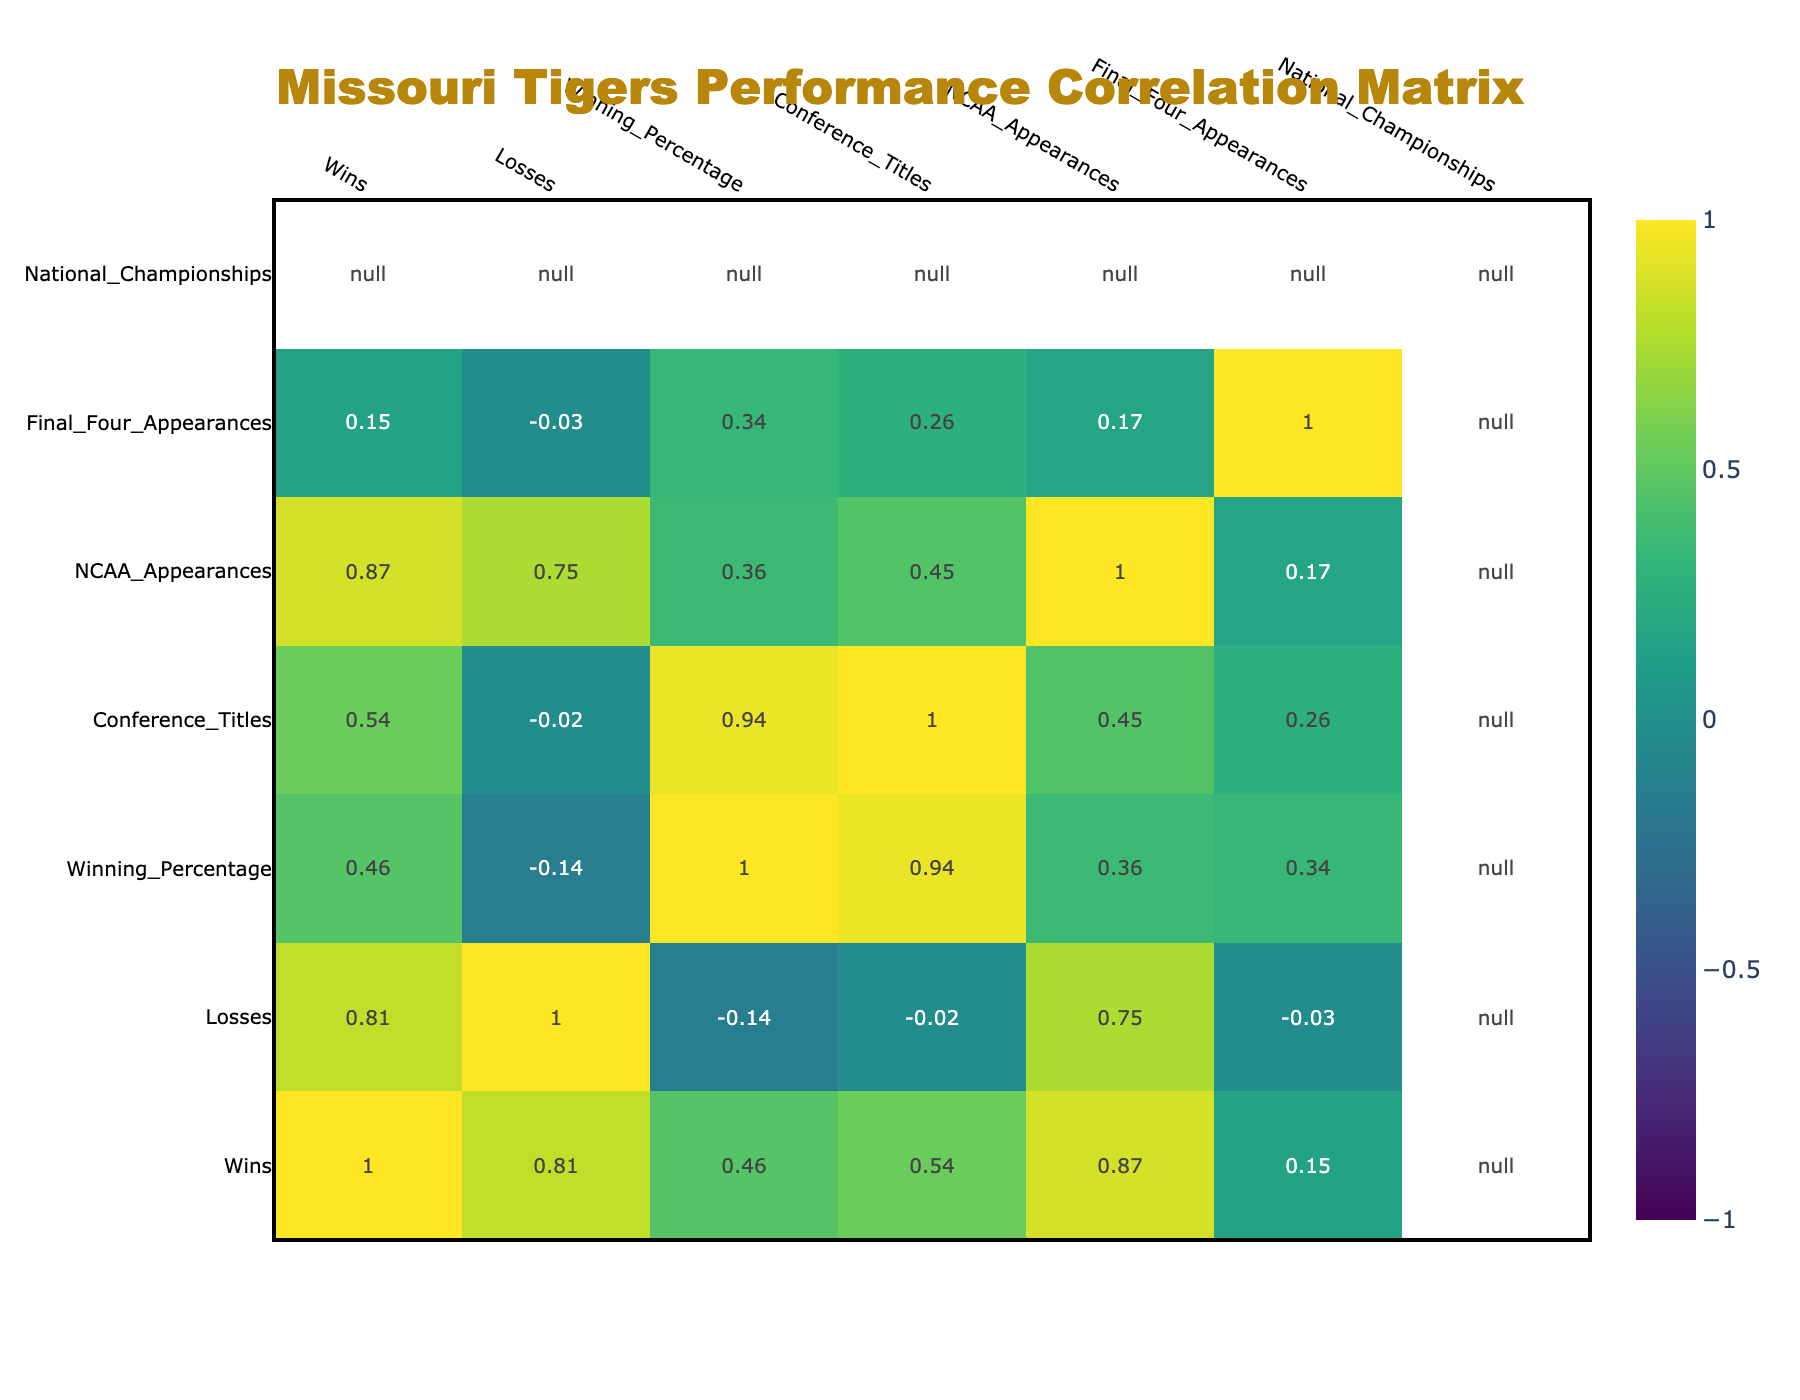What was the winning percentage of the Missouri Tigers in the 1980s? The table shows the winning percentage for the 1980s is listed under the "Winning_Percentage" column next to the "1980s" row. The value is 0.642.
Answer: 0.642 Which decade had the highest number of NCAA appearances? To find the decade with the highest number of NCAA appearances, I look under the "NCAA_Appearances" column and identify the maximum value. The 1990s has 7 appearances, which is the highest.
Answer: 1990s Is it true that the Missouri Tigers won any national championships in the 1970s? Checking the "National_Championships" column for the 1970s entry, the value is 0. Therefore, it is false that they won any national championships in that decade.
Answer: No What is the difference in winning percentage between the 1990s and 2000s? First, I note the winning percentage for the 1990s is 0.679 and for the 2000s is 0.576. The difference is 0.679 - 0.576 = 0.103.
Answer: 0.103 In which decade did the Missouri Tigers have the most conference titles? By looking at the "Conference_Titles" column, I see that the 1970s and 1990s both have 3 conference titles, which is the highest. Therefore, both decades can be considered.
Answer: 1970s and 1990s What is the average number of wins across all decades? To calculate the average number of wins, I first sum the wins across all decades (170 + 159 + 157 + 177 + 179 + 48 = 890) and then divide by the number of decades (6). The average is 890 / 6 ≈ 148.33.
Answer: 148.33 Did the Missouri Tigers have a Final Four appearance in the 2000s? Looking at the "Final_Four_Appearances" column for the 2000s, the value is 0, indicating there were no Final Four appearances in that decade.
Answer: No Which decade had the lowest winning percentage? I compare the winning percentages for each decade listed in the "Winning_Percentage" column. The 2000s has the lowest percentage at 0.576.
Answer: 2000s What is the total number of wins from the 1970s to the 2010s? I calculate the total wins by summing wins from the specified decades: 170 (1970s) + 159 (1980s) + 157 (1990s) + 177 (2000s) + 179 (2010s) = 842 wins.
Answer: 842 